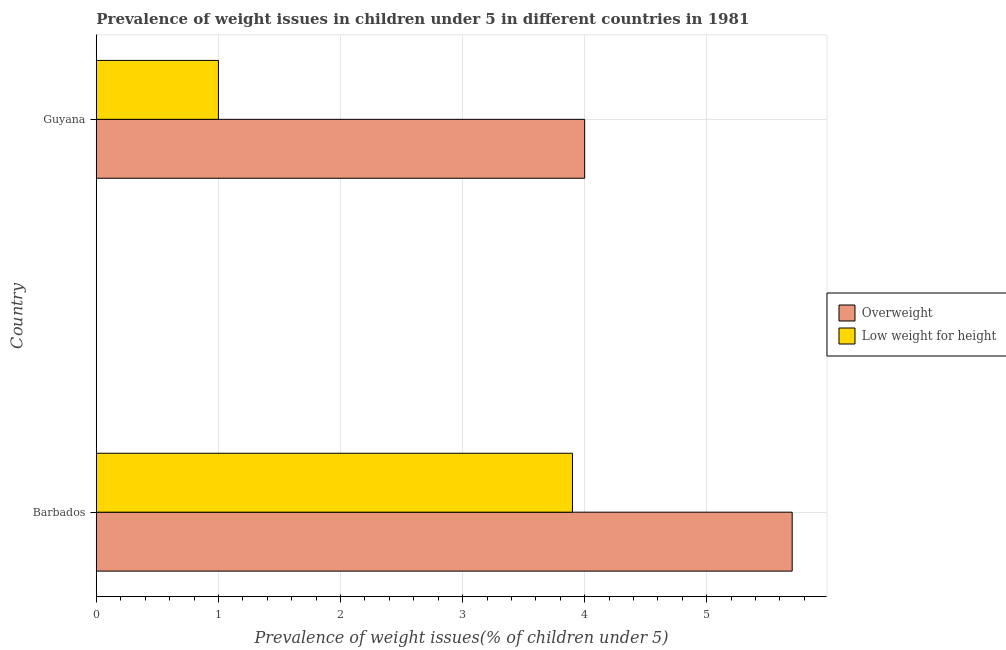Are the number of bars per tick equal to the number of legend labels?
Give a very brief answer. Yes. How many bars are there on the 2nd tick from the top?
Provide a succinct answer. 2. How many bars are there on the 2nd tick from the bottom?
Keep it short and to the point. 2. What is the label of the 1st group of bars from the top?
Make the answer very short. Guyana. Across all countries, what is the maximum percentage of overweight children?
Make the answer very short. 5.7. Across all countries, what is the minimum percentage of overweight children?
Your answer should be very brief. 4. In which country was the percentage of underweight children maximum?
Keep it short and to the point. Barbados. In which country was the percentage of underweight children minimum?
Provide a short and direct response. Guyana. What is the total percentage of underweight children in the graph?
Your response must be concise. 4.9. What is the difference between the percentage of underweight children in Barbados and that in Guyana?
Keep it short and to the point. 2.9. What is the difference between the percentage of overweight children in Guyana and the percentage of underweight children in Barbados?
Keep it short and to the point. 0.1. What is the average percentage of underweight children per country?
Your answer should be very brief. 2.45. In how many countries, is the percentage of underweight children greater than 4.8 %?
Your response must be concise. 0. What is the ratio of the percentage of underweight children in Barbados to that in Guyana?
Provide a succinct answer. 3.9. What does the 2nd bar from the top in Guyana represents?
Your answer should be compact. Overweight. What does the 1st bar from the bottom in Guyana represents?
Make the answer very short. Overweight. How many bars are there?
Make the answer very short. 4. What is the difference between two consecutive major ticks on the X-axis?
Provide a succinct answer. 1. Does the graph contain any zero values?
Your response must be concise. No. Where does the legend appear in the graph?
Provide a short and direct response. Center right. How many legend labels are there?
Provide a short and direct response. 2. How are the legend labels stacked?
Your answer should be very brief. Vertical. What is the title of the graph?
Provide a succinct answer. Prevalence of weight issues in children under 5 in different countries in 1981. What is the label or title of the X-axis?
Ensure brevity in your answer.  Prevalence of weight issues(% of children under 5). What is the Prevalence of weight issues(% of children under 5) of Overweight in Barbados?
Offer a terse response. 5.7. What is the Prevalence of weight issues(% of children under 5) of Low weight for height in Barbados?
Provide a succinct answer. 3.9. What is the Prevalence of weight issues(% of children under 5) in Overweight in Guyana?
Your answer should be compact. 4. Across all countries, what is the maximum Prevalence of weight issues(% of children under 5) of Overweight?
Offer a terse response. 5.7. Across all countries, what is the maximum Prevalence of weight issues(% of children under 5) of Low weight for height?
Keep it short and to the point. 3.9. Across all countries, what is the minimum Prevalence of weight issues(% of children under 5) in Low weight for height?
Make the answer very short. 1. What is the total Prevalence of weight issues(% of children under 5) of Low weight for height in the graph?
Offer a terse response. 4.9. What is the difference between the Prevalence of weight issues(% of children under 5) in Overweight in Barbados and that in Guyana?
Provide a succinct answer. 1.7. What is the difference between the Prevalence of weight issues(% of children under 5) in Overweight in Barbados and the Prevalence of weight issues(% of children under 5) in Low weight for height in Guyana?
Offer a terse response. 4.7. What is the average Prevalence of weight issues(% of children under 5) in Overweight per country?
Offer a terse response. 4.85. What is the average Prevalence of weight issues(% of children under 5) of Low weight for height per country?
Your response must be concise. 2.45. What is the difference between the Prevalence of weight issues(% of children under 5) of Overweight and Prevalence of weight issues(% of children under 5) of Low weight for height in Barbados?
Offer a terse response. 1.8. What is the ratio of the Prevalence of weight issues(% of children under 5) in Overweight in Barbados to that in Guyana?
Provide a succinct answer. 1.43. 